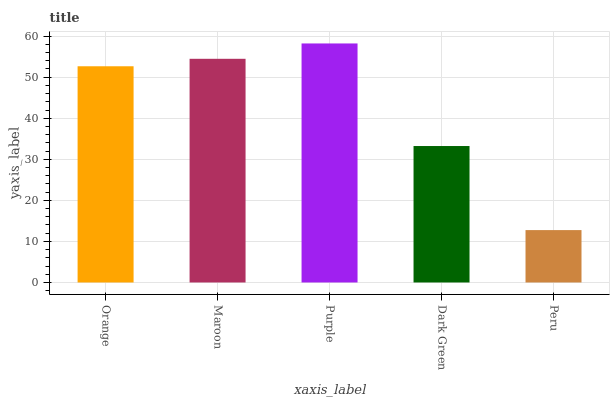Is Peru the minimum?
Answer yes or no. Yes. Is Purple the maximum?
Answer yes or no. Yes. Is Maroon the minimum?
Answer yes or no. No. Is Maroon the maximum?
Answer yes or no. No. Is Maroon greater than Orange?
Answer yes or no. Yes. Is Orange less than Maroon?
Answer yes or no. Yes. Is Orange greater than Maroon?
Answer yes or no. No. Is Maroon less than Orange?
Answer yes or no. No. Is Orange the high median?
Answer yes or no. Yes. Is Orange the low median?
Answer yes or no. Yes. Is Peru the high median?
Answer yes or no. No. Is Maroon the low median?
Answer yes or no. No. 